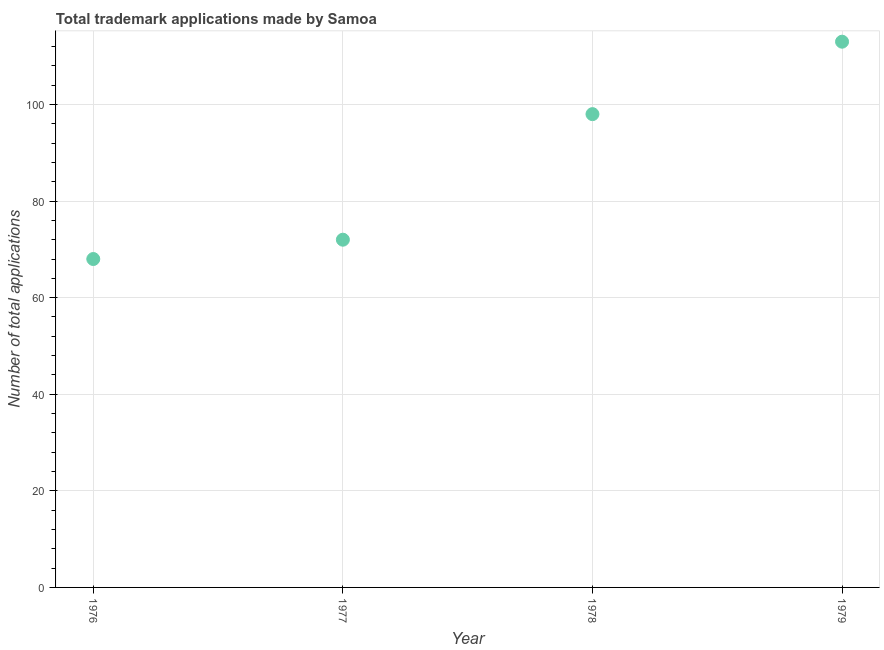What is the number of trademark applications in 1979?
Offer a very short reply. 113. Across all years, what is the maximum number of trademark applications?
Ensure brevity in your answer.  113. Across all years, what is the minimum number of trademark applications?
Give a very brief answer. 68. In which year was the number of trademark applications maximum?
Your answer should be compact. 1979. In which year was the number of trademark applications minimum?
Offer a terse response. 1976. What is the sum of the number of trademark applications?
Offer a terse response. 351. What is the difference between the number of trademark applications in 1976 and 1977?
Keep it short and to the point. -4. What is the average number of trademark applications per year?
Ensure brevity in your answer.  87.75. What is the median number of trademark applications?
Your response must be concise. 85. Do a majority of the years between 1979 and 1977 (inclusive) have number of trademark applications greater than 52 ?
Provide a short and direct response. No. What is the ratio of the number of trademark applications in 1978 to that in 1979?
Keep it short and to the point. 0.87. Is the number of trademark applications in 1977 less than that in 1979?
Provide a short and direct response. Yes. What is the difference between the highest and the second highest number of trademark applications?
Make the answer very short. 15. Is the sum of the number of trademark applications in 1976 and 1979 greater than the maximum number of trademark applications across all years?
Offer a very short reply. Yes. What is the difference between the highest and the lowest number of trademark applications?
Keep it short and to the point. 45. Does the number of trademark applications monotonically increase over the years?
Ensure brevity in your answer.  Yes. How many years are there in the graph?
Offer a terse response. 4. What is the difference between two consecutive major ticks on the Y-axis?
Provide a short and direct response. 20. Does the graph contain any zero values?
Keep it short and to the point. No. What is the title of the graph?
Your answer should be compact. Total trademark applications made by Samoa. What is the label or title of the X-axis?
Offer a very short reply. Year. What is the label or title of the Y-axis?
Offer a terse response. Number of total applications. What is the Number of total applications in 1979?
Ensure brevity in your answer.  113. What is the difference between the Number of total applications in 1976 and 1978?
Your response must be concise. -30. What is the difference between the Number of total applications in 1976 and 1979?
Keep it short and to the point. -45. What is the difference between the Number of total applications in 1977 and 1979?
Ensure brevity in your answer.  -41. What is the ratio of the Number of total applications in 1976 to that in 1977?
Your response must be concise. 0.94. What is the ratio of the Number of total applications in 1976 to that in 1978?
Your response must be concise. 0.69. What is the ratio of the Number of total applications in 1976 to that in 1979?
Your answer should be very brief. 0.6. What is the ratio of the Number of total applications in 1977 to that in 1978?
Your answer should be compact. 0.73. What is the ratio of the Number of total applications in 1977 to that in 1979?
Your response must be concise. 0.64. What is the ratio of the Number of total applications in 1978 to that in 1979?
Offer a terse response. 0.87. 